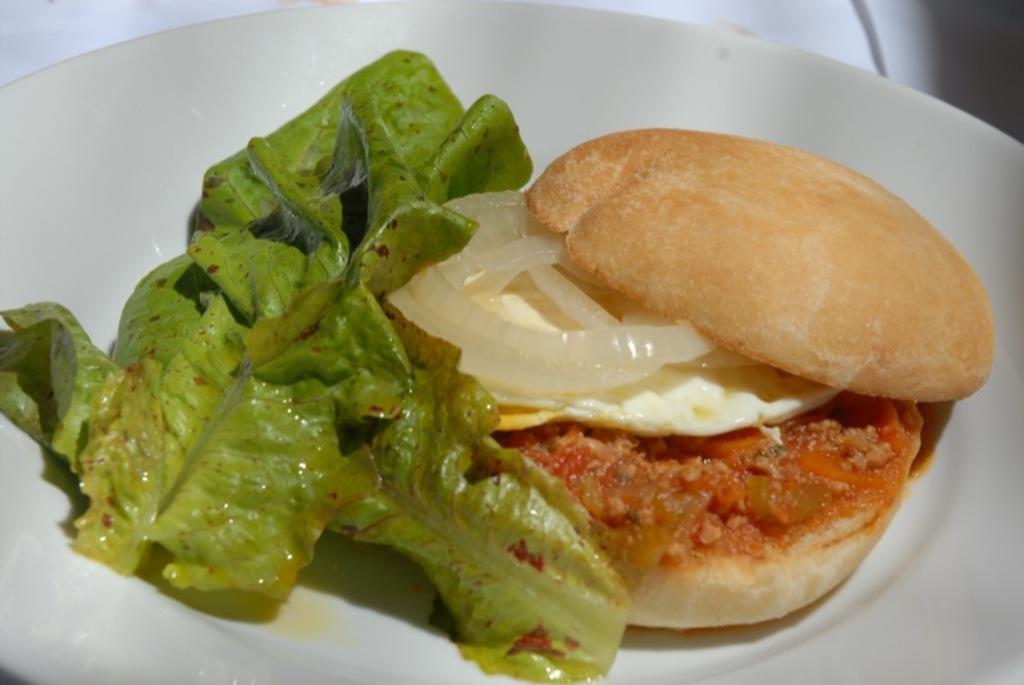How would you summarize this image in a sentence or two? In this image we can see a food item on the plate, there is a leaf. 